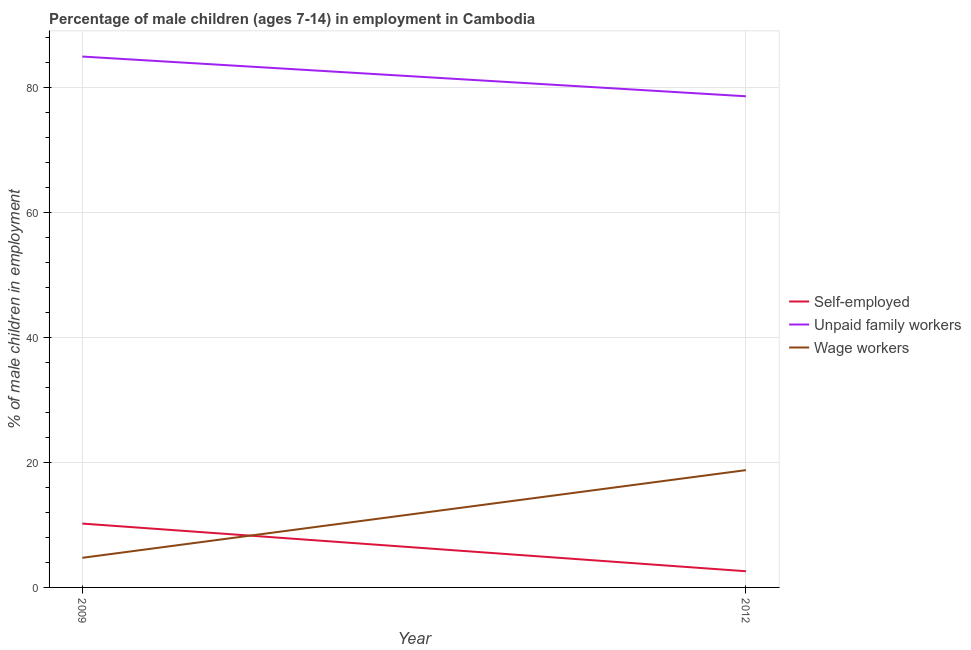How many different coloured lines are there?
Keep it short and to the point. 3. Is the number of lines equal to the number of legend labels?
Make the answer very short. Yes. What is the percentage of children employed as unpaid family workers in 2012?
Your answer should be very brief. 78.63. Across all years, what is the maximum percentage of children employed as unpaid family workers?
Ensure brevity in your answer.  84.99. Across all years, what is the minimum percentage of self employed children?
Offer a terse response. 2.59. In which year was the percentage of children employed as wage workers minimum?
Offer a terse response. 2009. What is the total percentage of self employed children in the graph?
Provide a succinct answer. 12.81. What is the difference between the percentage of children employed as wage workers in 2009 and that in 2012?
Keep it short and to the point. -14.04. What is the difference between the percentage of children employed as wage workers in 2012 and the percentage of self employed children in 2009?
Provide a succinct answer. 8.56. What is the average percentage of children employed as unpaid family workers per year?
Ensure brevity in your answer.  81.81. In the year 2009, what is the difference between the percentage of children employed as wage workers and percentage of self employed children?
Offer a very short reply. -5.48. In how many years, is the percentage of self employed children greater than 76 %?
Your answer should be compact. 0. What is the ratio of the percentage of self employed children in 2009 to that in 2012?
Provide a short and direct response. 3.95. In how many years, is the percentage of children employed as unpaid family workers greater than the average percentage of children employed as unpaid family workers taken over all years?
Offer a very short reply. 1. Is it the case that in every year, the sum of the percentage of self employed children and percentage of children employed as unpaid family workers is greater than the percentage of children employed as wage workers?
Provide a short and direct response. Yes. Does the percentage of self employed children monotonically increase over the years?
Ensure brevity in your answer.  No. Is the percentage of children employed as unpaid family workers strictly greater than the percentage of children employed as wage workers over the years?
Offer a terse response. Yes. Is the percentage of children employed as unpaid family workers strictly less than the percentage of children employed as wage workers over the years?
Ensure brevity in your answer.  No. How many years are there in the graph?
Provide a short and direct response. 2. Are the values on the major ticks of Y-axis written in scientific E-notation?
Make the answer very short. No. How many legend labels are there?
Ensure brevity in your answer.  3. What is the title of the graph?
Provide a short and direct response. Percentage of male children (ages 7-14) in employment in Cambodia. What is the label or title of the X-axis?
Your response must be concise. Year. What is the label or title of the Y-axis?
Provide a succinct answer. % of male children in employment. What is the % of male children in employment in Self-employed in 2009?
Keep it short and to the point. 10.22. What is the % of male children in employment of Unpaid family workers in 2009?
Make the answer very short. 84.99. What is the % of male children in employment in Wage workers in 2009?
Ensure brevity in your answer.  4.74. What is the % of male children in employment in Self-employed in 2012?
Ensure brevity in your answer.  2.59. What is the % of male children in employment of Unpaid family workers in 2012?
Your answer should be very brief. 78.63. What is the % of male children in employment in Wage workers in 2012?
Provide a short and direct response. 18.78. Across all years, what is the maximum % of male children in employment of Self-employed?
Offer a terse response. 10.22. Across all years, what is the maximum % of male children in employment of Unpaid family workers?
Your response must be concise. 84.99. Across all years, what is the maximum % of male children in employment in Wage workers?
Provide a succinct answer. 18.78. Across all years, what is the minimum % of male children in employment in Self-employed?
Give a very brief answer. 2.59. Across all years, what is the minimum % of male children in employment in Unpaid family workers?
Provide a succinct answer. 78.63. Across all years, what is the minimum % of male children in employment in Wage workers?
Provide a short and direct response. 4.74. What is the total % of male children in employment of Self-employed in the graph?
Make the answer very short. 12.81. What is the total % of male children in employment of Unpaid family workers in the graph?
Provide a succinct answer. 163.62. What is the total % of male children in employment in Wage workers in the graph?
Provide a succinct answer. 23.52. What is the difference between the % of male children in employment of Self-employed in 2009 and that in 2012?
Keep it short and to the point. 7.63. What is the difference between the % of male children in employment of Unpaid family workers in 2009 and that in 2012?
Your answer should be very brief. 6.36. What is the difference between the % of male children in employment in Wage workers in 2009 and that in 2012?
Provide a short and direct response. -14.04. What is the difference between the % of male children in employment in Self-employed in 2009 and the % of male children in employment in Unpaid family workers in 2012?
Your answer should be very brief. -68.41. What is the difference between the % of male children in employment in Self-employed in 2009 and the % of male children in employment in Wage workers in 2012?
Give a very brief answer. -8.56. What is the difference between the % of male children in employment of Unpaid family workers in 2009 and the % of male children in employment of Wage workers in 2012?
Your answer should be compact. 66.21. What is the average % of male children in employment of Self-employed per year?
Offer a very short reply. 6.41. What is the average % of male children in employment of Unpaid family workers per year?
Give a very brief answer. 81.81. What is the average % of male children in employment in Wage workers per year?
Your answer should be compact. 11.76. In the year 2009, what is the difference between the % of male children in employment in Self-employed and % of male children in employment in Unpaid family workers?
Make the answer very short. -74.77. In the year 2009, what is the difference between the % of male children in employment in Self-employed and % of male children in employment in Wage workers?
Give a very brief answer. 5.48. In the year 2009, what is the difference between the % of male children in employment in Unpaid family workers and % of male children in employment in Wage workers?
Your answer should be very brief. 80.25. In the year 2012, what is the difference between the % of male children in employment of Self-employed and % of male children in employment of Unpaid family workers?
Your answer should be very brief. -76.04. In the year 2012, what is the difference between the % of male children in employment in Self-employed and % of male children in employment in Wage workers?
Provide a short and direct response. -16.19. In the year 2012, what is the difference between the % of male children in employment in Unpaid family workers and % of male children in employment in Wage workers?
Provide a succinct answer. 59.85. What is the ratio of the % of male children in employment of Self-employed in 2009 to that in 2012?
Offer a terse response. 3.95. What is the ratio of the % of male children in employment in Unpaid family workers in 2009 to that in 2012?
Give a very brief answer. 1.08. What is the ratio of the % of male children in employment of Wage workers in 2009 to that in 2012?
Provide a succinct answer. 0.25. What is the difference between the highest and the second highest % of male children in employment in Self-employed?
Your answer should be very brief. 7.63. What is the difference between the highest and the second highest % of male children in employment in Unpaid family workers?
Keep it short and to the point. 6.36. What is the difference between the highest and the second highest % of male children in employment in Wage workers?
Your answer should be compact. 14.04. What is the difference between the highest and the lowest % of male children in employment in Self-employed?
Make the answer very short. 7.63. What is the difference between the highest and the lowest % of male children in employment of Unpaid family workers?
Your response must be concise. 6.36. What is the difference between the highest and the lowest % of male children in employment of Wage workers?
Keep it short and to the point. 14.04. 